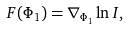<formula> <loc_0><loc_0><loc_500><loc_500>F ( \Phi _ { 1 } ) = \nabla _ { \Phi _ { 1 } } \ln I ,</formula> 